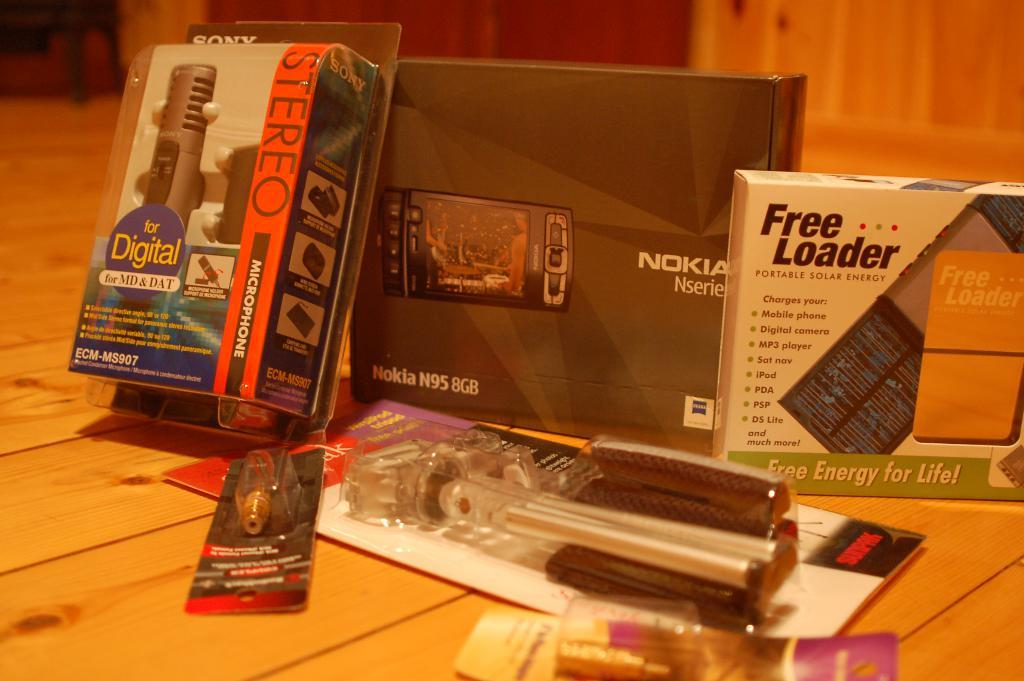What is located in the center of the image? There are boxes in the center of the image. What can be seen on the boxes? There is text written on the boxes. What is in front of the boxes in the image? There are objects on a surface in front of the boxes. What is the color of the surface? The surface is brown in color. How does the fly grip the quiver in the image? There is no fly or quiver present in the image. 